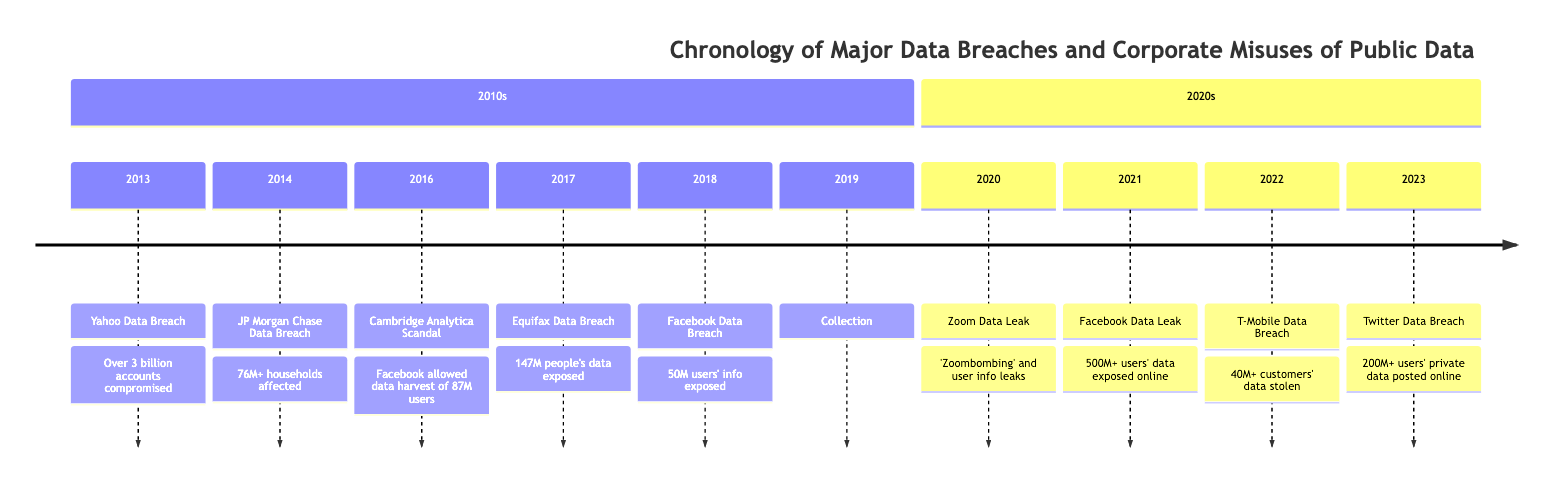What year did the Yahoo Data Breach occur? The timeline indicates that the Yahoo Data Breach happened in the year 2013. This specific event is positioned at the beginning of the 2010s section of the diagram.
Answer: 2013 How many accounts were compromised in the Yahoo Data Breach? The details provided alongside the Yahoo Data Breach state that over 3 billion accounts were compromised, as explicitly mentioned in the description of that event in the timeline.
Answer: Over 3 billion Which company's data breach exposed 147 million people's information? The timeline clearly shows that the Equifax Data Breach in 2017 resulted in the exposure of personally identifiable information of 147 million people, as outlined in that event's details.
Answer: Equifax What is the last event listed in the timeline? The timeline's layout reveals that the most recent event is the Twitter Data Breach in 2023, which is the last entry under the 2020s section.
Answer: Twitter Data Breach Which data breach involved the harvesting of data from 87 million users? The Cambridge Analytica Scandal is the event that specifically involved Facebook allowing for the harvesting of data from up to 87 million users without their explicit consent, as noted in the timeline.
Answer: Cambridge Analytica Scandal How many email addresses were exposed in the Collection #1 Data Breach? The timeline specifies that the Collection #1 Data Breach released a massive trove of 773 million email addresses, as well as other data, making this information readily available from the timeline entry.
Answer: 773 million Which event had the highest number of users affected in the 2010s? Comparing the various events in the 2010s section of the timeline, the Yahoo Data Breach, which compromised over 3 billion accounts, is the event with the highest number of users affected.
Answer: Yahoo Data Breach What type of incident occurred with Zoom in 2020? The timeline indicates that in 2020, Zoom faced a data leak characterized by incidents of 'Zoombombing' and the leaking of private information, specifically mentioned in that year's description.
Answer: Data Leak How many phone numbers were exposed in the Facebook Data Leak of 2021? The timeline reveals that the Facebook Data Leak in 2021 exposed the phone numbers and personal data of more than 500 million users, directly stated in the details of that event.
Answer: 500 million 